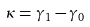<formula> <loc_0><loc_0><loc_500><loc_500>\kappa = \gamma _ { 1 } - \gamma _ { 0 }</formula> 